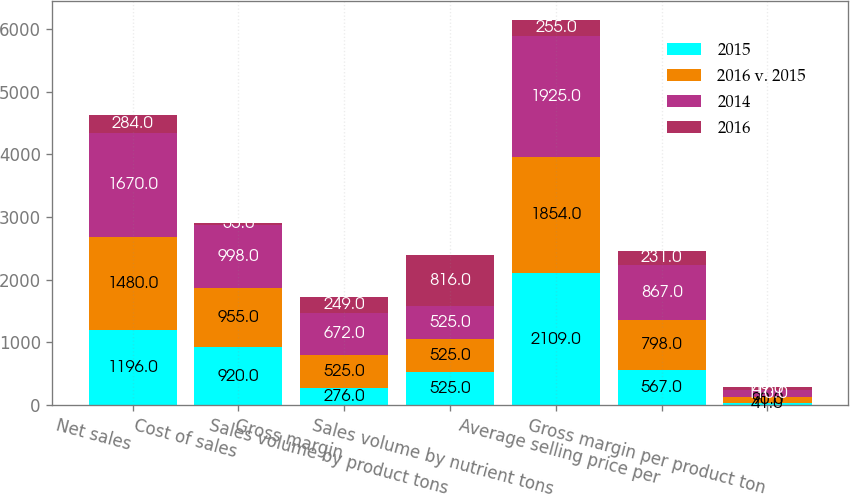Convert chart to OTSL. <chart><loc_0><loc_0><loc_500><loc_500><stacked_bar_chart><ecel><fcel>Net sales<fcel>Cost of sales<fcel>Gross margin<fcel>Sales volume by product tons<fcel>Sales volume by nutrient tons<fcel>Average selling price per<fcel>Gross margin per product ton<nl><fcel>2015<fcel>1196<fcel>920<fcel>276<fcel>525<fcel>2109<fcel>567<fcel>41<nl><fcel>2016 v. 2015<fcel>1480<fcel>955<fcel>525<fcel>525<fcel>1854<fcel>798<fcel>90<nl><fcel>2014<fcel>1670<fcel>998<fcel>672<fcel>525<fcel>1925<fcel>867<fcel>110<nl><fcel>2016<fcel>284<fcel>35<fcel>249<fcel>816<fcel>255<fcel>231<fcel>49<nl></chart> 